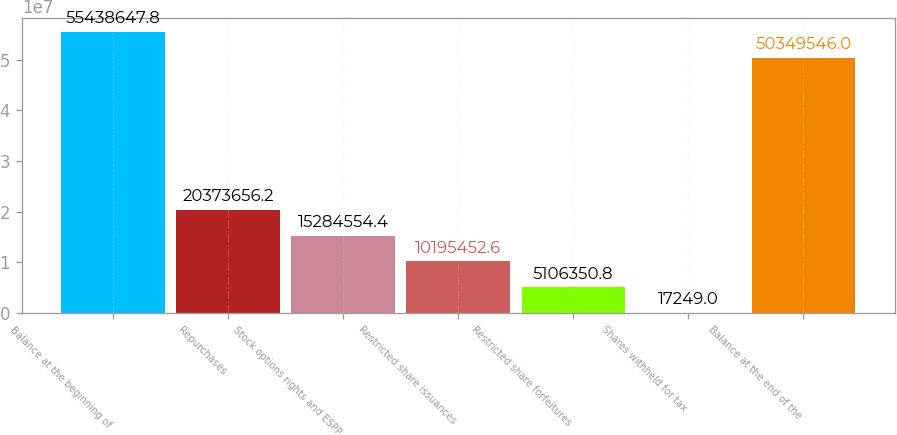Convert chart. <chart><loc_0><loc_0><loc_500><loc_500><bar_chart><fcel>Balance at the beginning of<fcel>Repurchases<fcel>Stock options rights and ESPP<fcel>Restricted share issuances<fcel>Restricted share forfeitures<fcel>Shares withheld for tax<fcel>Balance at the end of the<nl><fcel>5.54386e+07<fcel>2.03737e+07<fcel>1.52846e+07<fcel>1.01955e+07<fcel>5.10635e+06<fcel>17249<fcel>5.03495e+07<nl></chart> 